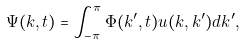<formula> <loc_0><loc_0><loc_500><loc_500>\Psi ( k , t ) = \int _ { - \pi } ^ { \pi } \Phi ( k ^ { \prime } , t ) u ( k , k ^ { \prime } ) d k ^ { \prime } ,</formula> 